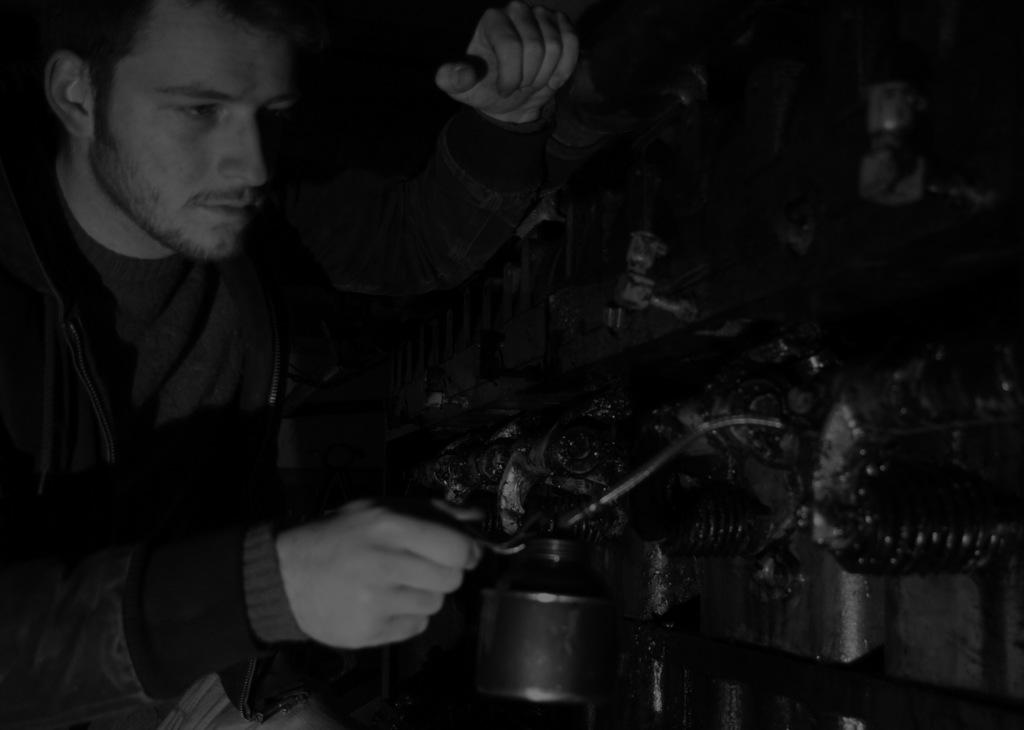What is the color scheme of the image? The image is black and white. Who is present in the image? There is a man in the image. What is the man doing in the image? The man is holding an object. What can be seen behind the man in the image? There is machinery in front of the man. What type of club does the minister belong to in the image? There is no minister or club present in the image. What are the man's hobbies, as depicted in the image? The image does not provide information about the man's hobbies. 